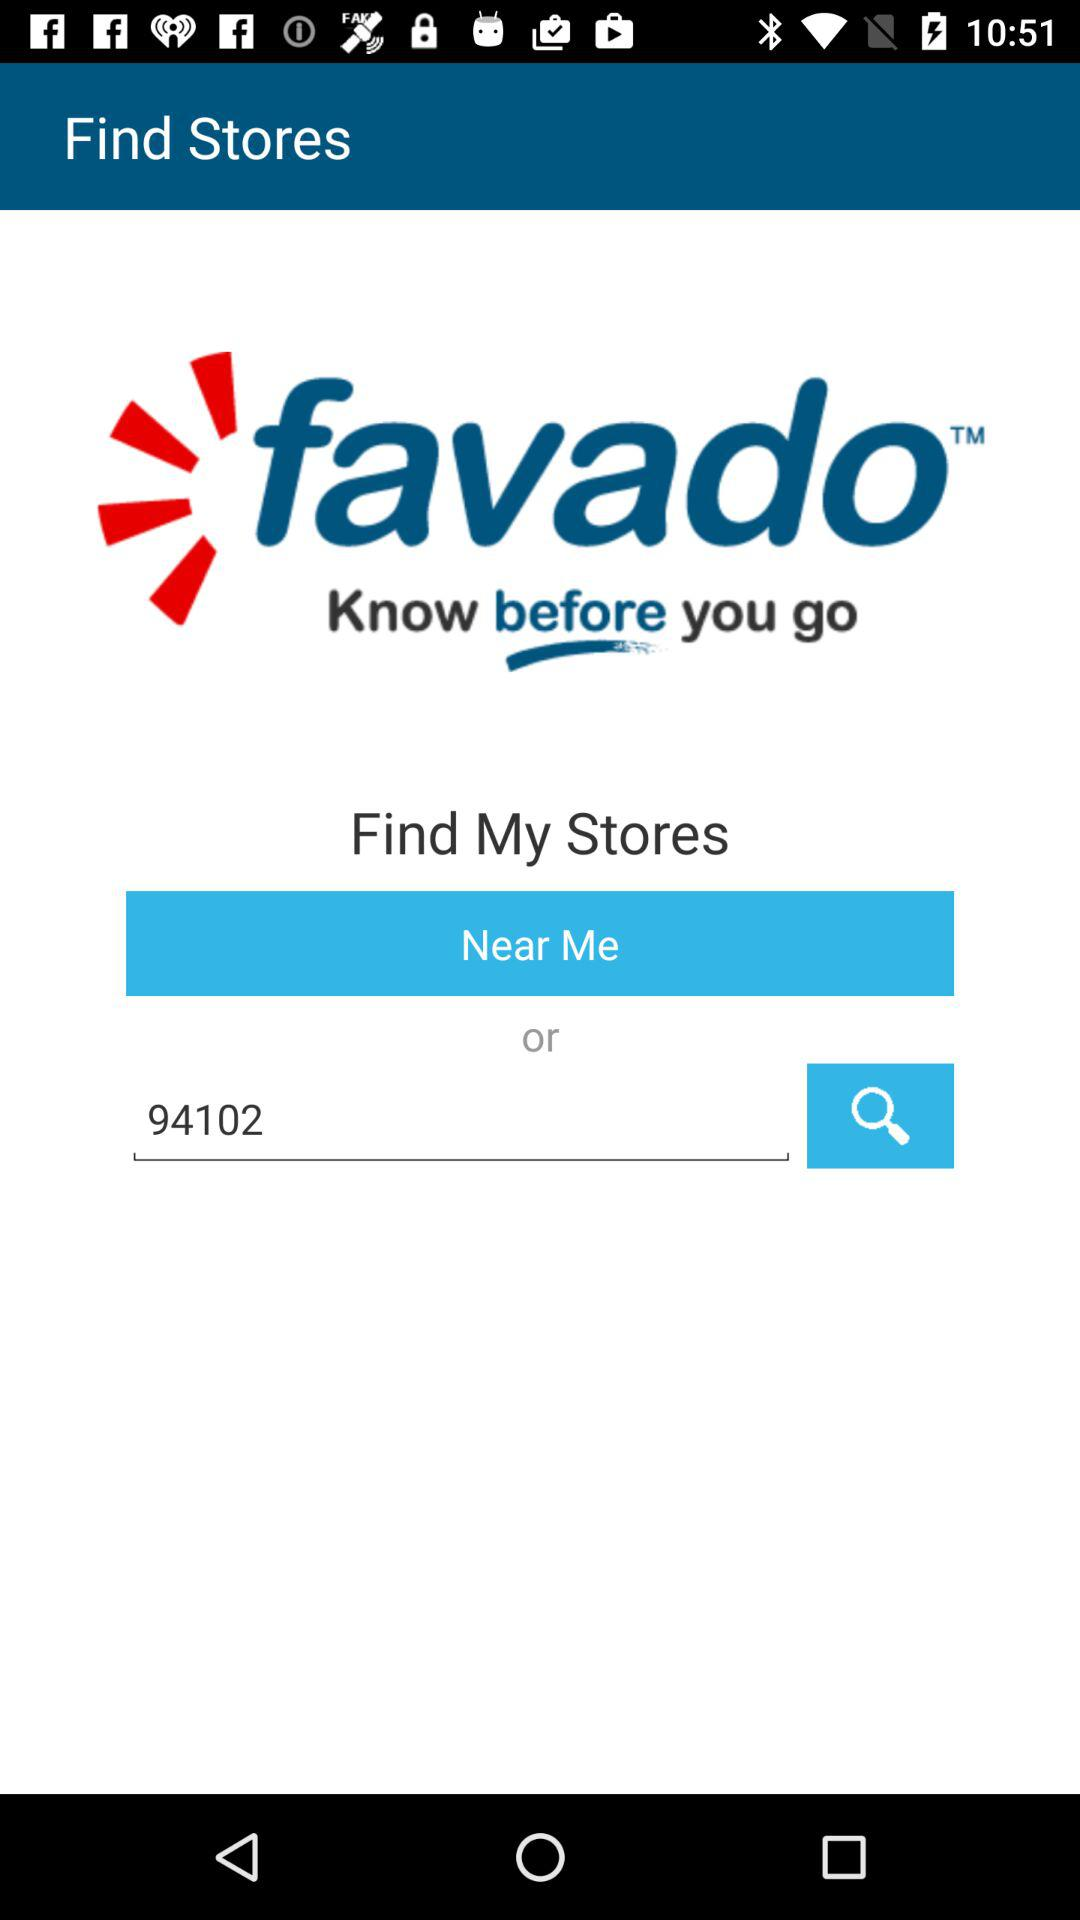Where is the nearest store location?
When the provided information is insufficient, respond with <no answer>. <no answer> 